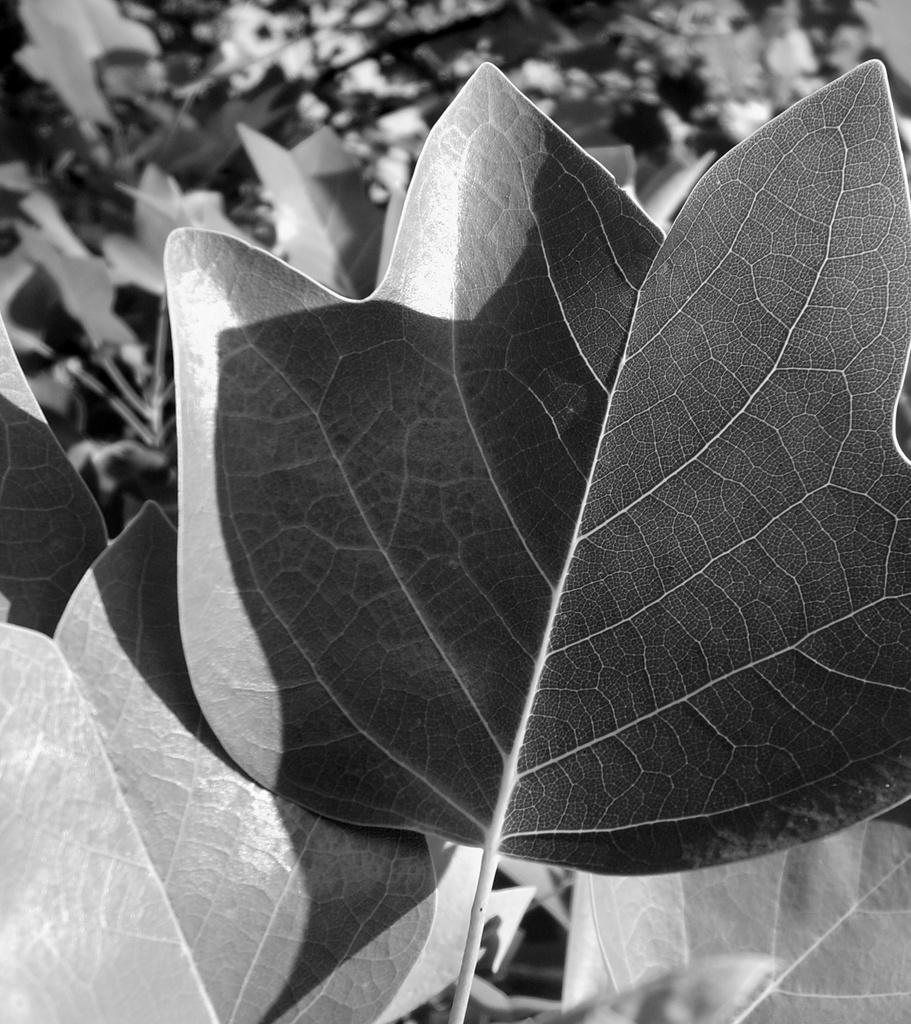What type of natural elements can be seen in the image? There are leaves and plants in the image. How is the background of the image depicted? The background of the image has a blurred view. What is the color scheme of the image? The image is black and white. Can you tell me how many geese are talking about their journey in the image? There are no geese or any indication of a journey in the image; it features leaves and plants in a black and white, blurred background. 